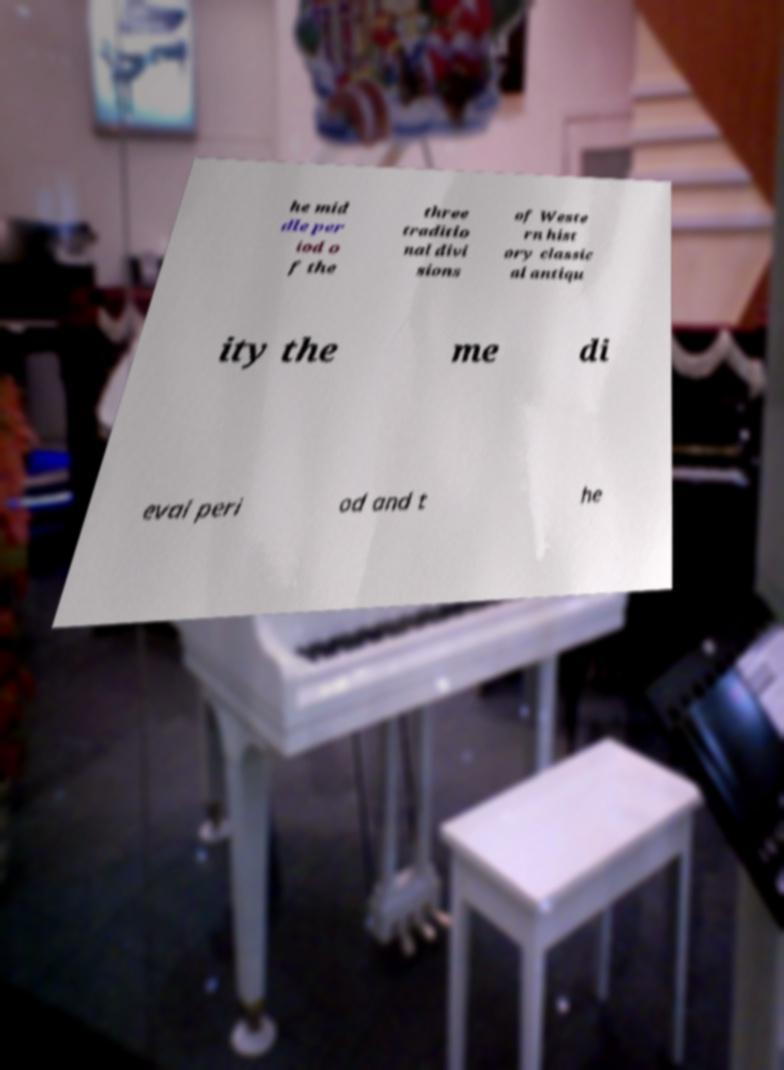Please identify and transcribe the text found in this image. he mid dle per iod o f the three traditio nal divi sions of Weste rn hist ory classic al antiqu ity the me di eval peri od and t he 